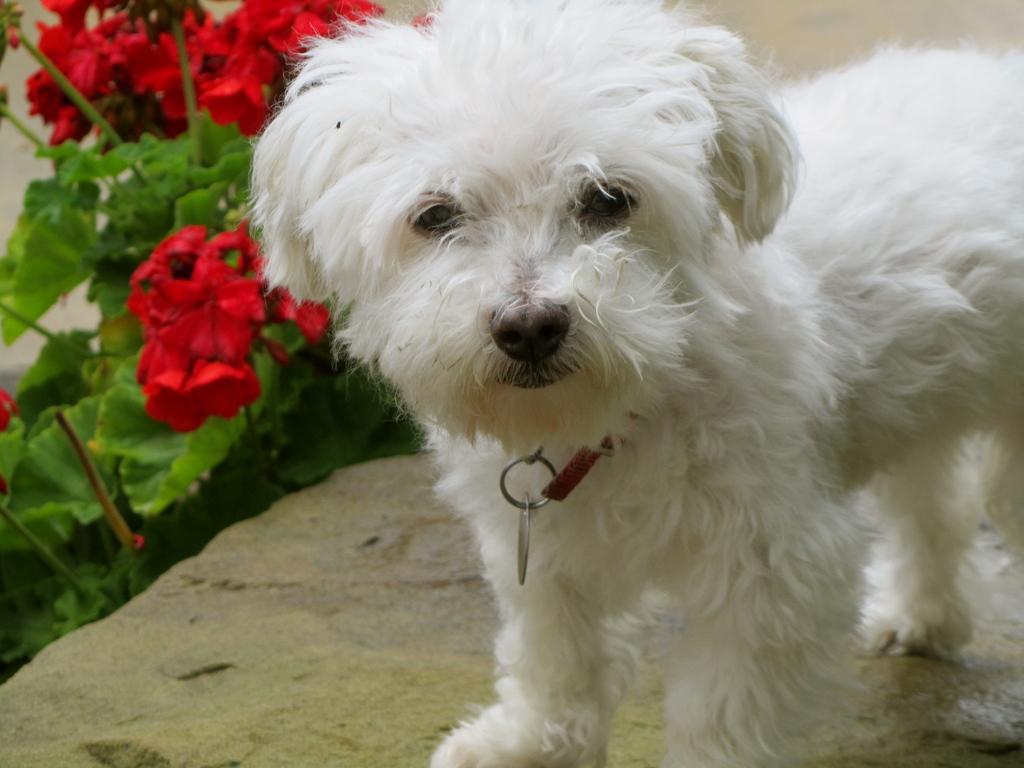Describe this image in one or two sentences. In this image I can see a white colour dog. In the background I can see few red colour flowers and green leaves. 